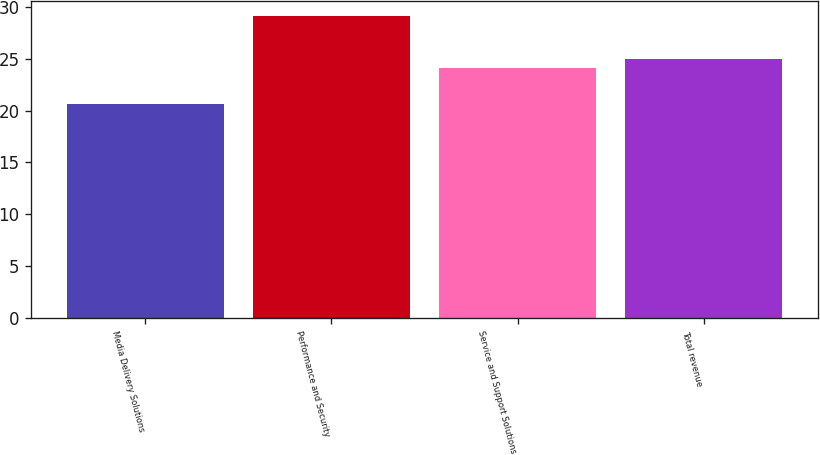Convert chart. <chart><loc_0><loc_0><loc_500><loc_500><bar_chart><fcel>Media Delivery Solutions<fcel>Performance and Security<fcel>Service and Support Solutions<fcel>Total revenue<nl><fcel>20.6<fcel>29.1<fcel>24.1<fcel>24.95<nl></chart> 